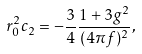<formula> <loc_0><loc_0><loc_500><loc_500>r _ { 0 } ^ { 2 } c _ { 2 } = - \frac { 3 } { 4 } \frac { 1 + 3 g ^ { 2 } } { ( 4 \pi f ) ^ { 2 } } ,</formula> 